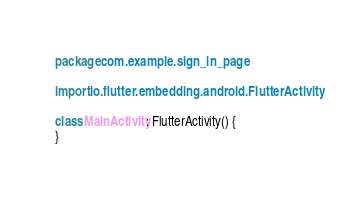Convert code to text. <code><loc_0><loc_0><loc_500><loc_500><_Kotlin_>package com.example.sign_in_page

import io.flutter.embedding.android.FlutterActivity

class MainActivity: FlutterActivity() {
}
</code> 